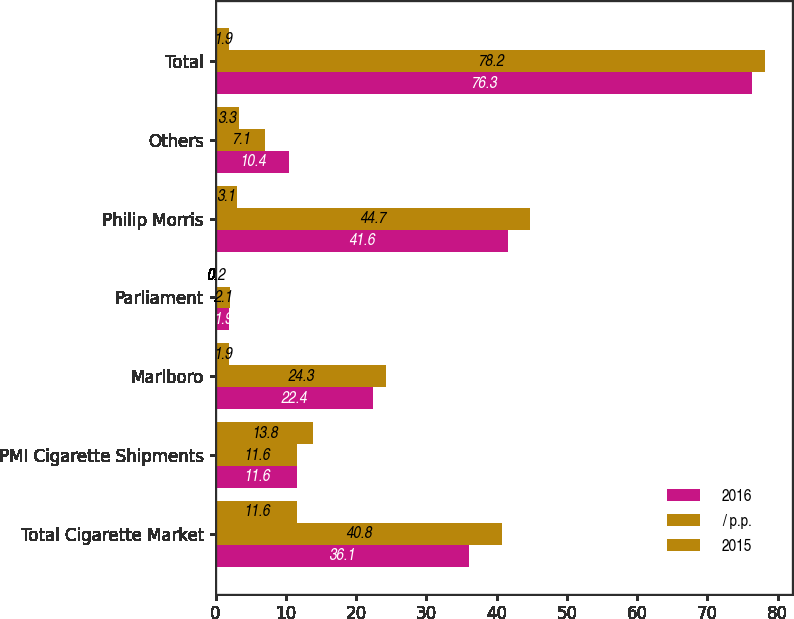<chart> <loc_0><loc_0><loc_500><loc_500><stacked_bar_chart><ecel><fcel>Total Cigarette Market<fcel>PMI Cigarette Shipments<fcel>Marlboro<fcel>Parliament<fcel>Philip Morris<fcel>Others<fcel>Total<nl><fcel>2016<fcel>36.1<fcel>11.6<fcel>22.4<fcel>1.9<fcel>41.6<fcel>10.4<fcel>76.3<nl><fcel>/ p.p.<fcel>40.8<fcel>11.6<fcel>24.3<fcel>2.1<fcel>44.7<fcel>7.1<fcel>78.2<nl><fcel>2015<fcel>11.6<fcel>13.8<fcel>1.9<fcel>0.2<fcel>3.1<fcel>3.3<fcel>1.9<nl></chart> 